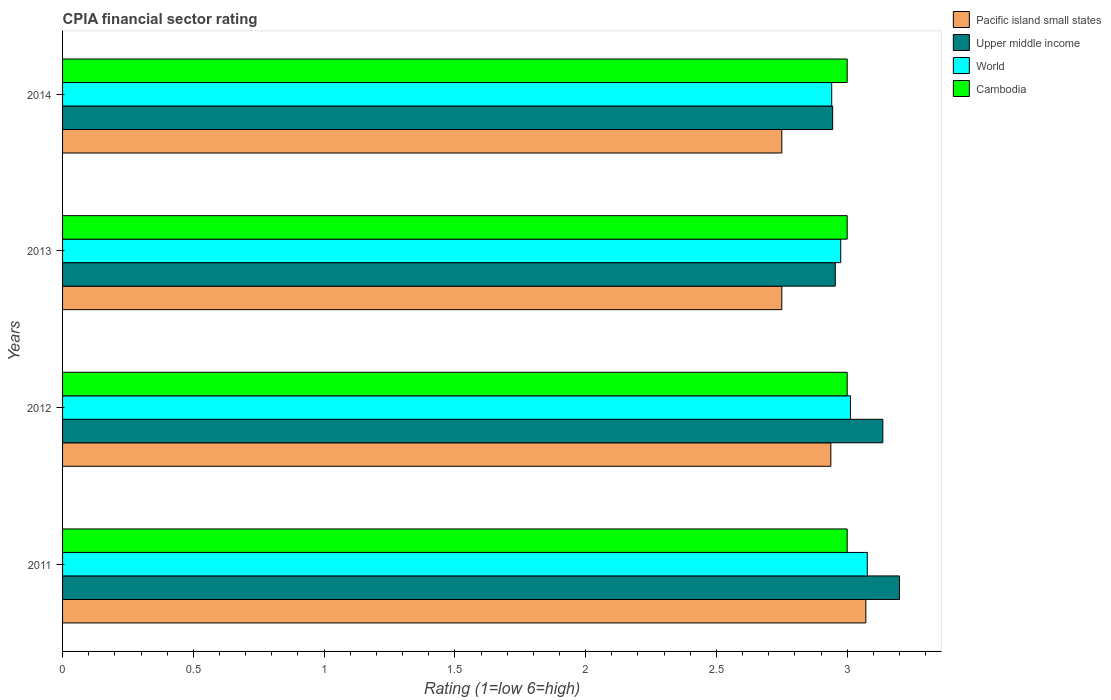How many groups of bars are there?
Keep it short and to the point. 4. Are the number of bars per tick equal to the number of legend labels?
Make the answer very short. Yes. Are the number of bars on each tick of the Y-axis equal?
Your answer should be very brief. Yes. How many bars are there on the 4th tick from the bottom?
Keep it short and to the point. 4. What is the label of the 4th group of bars from the top?
Offer a very short reply. 2011. What is the CPIA rating in World in 2014?
Ensure brevity in your answer.  2.94. Across all years, what is the maximum CPIA rating in Pacific island small states?
Give a very brief answer. 3.07. In which year was the CPIA rating in World minimum?
Keep it short and to the point. 2014. What is the total CPIA rating in World in the graph?
Offer a very short reply. 12.01. What is the difference between the CPIA rating in Upper middle income in 2014 and the CPIA rating in Pacific island small states in 2012?
Your answer should be compact. 0.01. What is the average CPIA rating in Pacific island small states per year?
Offer a very short reply. 2.88. In the year 2014, what is the difference between the CPIA rating in Cambodia and CPIA rating in Upper middle income?
Provide a succinct answer. 0.06. Is the difference between the CPIA rating in Cambodia in 2011 and 2012 greater than the difference between the CPIA rating in Upper middle income in 2011 and 2012?
Offer a very short reply. No. What is the difference between the highest and the second highest CPIA rating in World?
Ensure brevity in your answer.  0.06. What is the difference between the highest and the lowest CPIA rating in Pacific island small states?
Offer a very short reply. 0.32. In how many years, is the CPIA rating in Pacific island small states greater than the average CPIA rating in Pacific island small states taken over all years?
Ensure brevity in your answer.  2. Is the sum of the CPIA rating in World in 2012 and 2014 greater than the maximum CPIA rating in Pacific island small states across all years?
Provide a short and direct response. Yes. Is it the case that in every year, the sum of the CPIA rating in Cambodia and CPIA rating in World is greater than the sum of CPIA rating in Upper middle income and CPIA rating in Pacific island small states?
Keep it short and to the point. No. What does the 2nd bar from the top in 2013 represents?
Your answer should be compact. World. What does the 2nd bar from the bottom in 2013 represents?
Keep it short and to the point. Upper middle income. What is the difference between two consecutive major ticks on the X-axis?
Make the answer very short. 0.5. Are the values on the major ticks of X-axis written in scientific E-notation?
Your answer should be very brief. No. Does the graph contain any zero values?
Make the answer very short. No. Does the graph contain grids?
Keep it short and to the point. No. How many legend labels are there?
Offer a terse response. 4. What is the title of the graph?
Your response must be concise. CPIA financial sector rating. What is the label or title of the X-axis?
Give a very brief answer. Rating (1=low 6=high). What is the Rating (1=low 6=high) in Pacific island small states in 2011?
Offer a terse response. 3.07. What is the Rating (1=low 6=high) of World in 2011?
Your answer should be compact. 3.08. What is the Rating (1=low 6=high) in Cambodia in 2011?
Make the answer very short. 3. What is the Rating (1=low 6=high) in Pacific island small states in 2012?
Keep it short and to the point. 2.94. What is the Rating (1=low 6=high) of Upper middle income in 2012?
Ensure brevity in your answer.  3.14. What is the Rating (1=low 6=high) of World in 2012?
Your answer should be very brief. 3.01. What is the Rating (1=low 6=high) in Cambodia in 2012?
Provide a short and direct response. 3. What is the Rating (1=low 6=high) of Pacific island small states in 2013?
Your response must be concise. 2.75. What is the Rating (1=low 6=high) of Upper middle income in 2013?
Make the answer very short. 2.95. What is the Rating (1=low 6=high) in World in 2013?
Make the answer very short. 2.98. What is the Rating (1=low 6=high) in Pacific island small states in 2014?
Your answer should be compact. 2.75. What is the Rating (1=low 6=high) of Upper middle income in 2014?
Your answer should be very brief. 2.94. What is the Rating (1=low 6=high) in World in 2014?
Your answer should be very brief. 2.94. What is the Rating (1=low 6=high) of Cambodia in 2014?
Your answer should be compact. 3. Across all years, what is the maximum Rating (1=low 6=high) in Pacific island small states?
Provide a short and direct response. 3.07. Across all years, what is the maximum Rating (1=low 6=high) of World?
Ensure brevity in your answer.  3.08. Across all years, what is the minimum Rating (1=low 6=high) of Pacific island small states?
Make the answer very short. 2.75. Across all years, what is the minimum Rating (1=low 6=high) in Upper middle income?
Provide a succinct answer. 2.94. Across all years, what is the minimum Rating (1=low 6=high) of World?
Ensure brevity in your answer.  2.94. What is the total Rating (1=low 6=high) in Pacific island small states in the graph?
Make the answer very short. 11.51. What is the total Rating (1=low 6=high) of Upper middle income in the graph?
Give a very brief answer. 12.24. What is the total Rating (1=low 6=high) in World in the graph?
Keep it short and to the point. 12.01. What is the difference between the Rating (1=low 6=high) of Pacific island small states in 2011 and that in 2012?
Provide a succinct answer. 0.13. What is the difference between the Rating (1=low 6=high) of Upper middle income in 2011 and that in 2012?
Your response must be concise. 0.06. What is the difference between the Rating (1=low 6=high) of World in 2011 and that in 2012?
Offer a very short reply. 0.06. What is the difference between the Rating (1=low 6=high) in Cambodia in 2011 and that in 2012?
Provide a short and direct response. 0. What is the difference between the Rating (1=low 6=high) in Pacific island small states in 2011 and that in 2013?
Your response must be concise. 0.32. What is the difference between the Rating (1=low 6=high) in Upper middle income in 2011 and that in 2013?
Offer a terse response. 0.25. What is the difference between the Rating (1=low 6=high) of World in 2011 and that in 2013?
Your answer should be very brief. 0.1. What is the difference between the Rating (1=low 6=high) in Pacific island small states in 2011 and that in 2014?
Ensure brevity in your answer.  0.32. What is the difference between the Rating (1=low 6=high) of Upper middle income in 2011 and that in 2014?
Provide a succinct answer. 0.26. What is the difference between the Rating (1=low 6=high) in World in 2011 and that in 2014?
Ensure brevity in your answer.  0.14. What is the difference between the Rating (1=low 6=high) of Pacific island small states in 2012 and that in 2013?
Ensure brevity in your answer.  0.19. What is the difference between the Rating (1=low 6=high) in Upper middle income in 2012 and that in 2013?
Keep it short and to the point. 0.18. What is the difference between the Rating (1=low 6=high) of World in 2012 and that in 2013?
Offer a very short reply. 0.04. What is the difference between the Rating (1=low 6=high) in Pacific island small states in 2012 and that in 2014?
Provide a succinct answer. 0.19. What is the difference between the Rating (1=low 6=high) in Upper middle income in 2012 and that in 2014?
Provide a short and direct response. 0.19. What is the difference between the Rating (1=low 6=high) in World in 2012 and that in 2014?
Offer a very short reply. 0.07. What is the difference between the Rating (1=low 6=high) in Upper middle income in 2013 and that in 2014?
Offer a terse response. 0.01. What is the difference between the Rating (1=low 6=high) of World in 2013 and that in 2014?
Your answer should be very brief. 0.03. What is the difference between the Rating (1=low 6=high) of Pacific island small states in 2011 and the Rating (1=low 6=high) of Upper middle income in 2012?
Provide a short and direct response. -0.06. What is the difference between the Rating (1=low 6=high) in Pacific island small states in 2011 and the Rating (1=low 6=high) in World in 2012?
Keep it short and to the point. 0.06. What is the difference between the Rating (1=low 6=high) of Pacific island small states in 2011 and the Rating (1=low 6=high) of Cambodia in 2012?
Give a very brief answer. 0.07. What is the difference between the Rating (1=low 6=high) in Upper middle income in 2011 and the Rating (1=low 6=high) in World in 2012?
Ensure brevity in your answer.  0.19. What is the difference between the Rating (1=low 6=high) in World in 2011 and the Rating (1=low 6=high) in Cambodia in 2012?
Offer a terse response. 0.08. What is the difference between the Rating (1=low 6=high) of Pacific island small states in 2011 and the Rating (1=low 6=high) of Upper middle income in 2013?
Provide a short and direct response. 0.12. What is the difference between the Rating (1=low 6=high) of Pacific island small states in 2011 and the Rating (1=low 6=high) of World in 2013?
Keep it short and to the point. 0.1. What is the difference between the Rating (1=low 6=high) of Pacific island small states in 2011 and the Rating (1=low 6=high) of Cambodia in 2013?
Offer a very short reply. 0.07. What is the difference between the Rating (1=low 6=high) in Upper middle income in 2011 and the Rating (1=low 6=high) in World in 2013?
Provide a short and direct response. 0.22. What is the difference between the Rating (1=low 6=high) of World in 2011 and the Rating (1=low 6=high) of Cambodia in 2013?
Your answer should be very brief. 0.08. What is the difference between the Rating (1=low 6=high) of Pacific island small states in 2011 and the Rating (1=low 6=high) of Upper middle income in 2014?
Your answer should be very brief. 0.13. What is the difference between the Rating (1=low 6=high) in Pacific island small states in 2011 and the Rating (1=low 6=high) in World in 2014?
Your answer should be compact. 0.13. What is the difference between the Rating (1=low 6=high) of Pacific island small states in 2011 and the Rating (1=low 6=high) of Cambodia in 2014?
Offer a terse response. 0.07. What is the difference between the Rating (1=low 6=high) of Upper middle income in 2011 and the Rating (1=low 6=high) of World in 2014?
Offer a very short reply. 0.26. What is the difference between the Rating (1=low 6=high) of Upper middle income in 2011 and the Rating (1=low 6=high) of Cambodia in 2014?
Give a very brief answer. 0.2. What is the difference between the Rating (1=low 6=high) in World in 2011 and the Rating (1=low 6=high) in Cambodia in 2014?
Provide a succinct answer. 0.08. What is the difference between the Rating (1=low 6=high) of Pacific island small states in 2012 and the Rating (1=low 6=high) of Upper middle income in 2013?
Provide a short and direct response. -0.02. What is the difference between the Rating (1=low 6=high) of Pacific island small states in 2012 and the Rating (1=low 6=high) of World in 2013?
Provide a short and direct response. -0.04. What is the difference between the Rating (1=low 6=high) of Pacific island small states in 2012 and the Rating (1=low 6=high) of Cambodia in 2013?
Your response must be concise. -0.06. What is the difference between the Rating (1=low 6=high) of Upper middle income in 2012 and the Rating (1=low 6=high) of World in 2013?
Offer a terse response. 0.16. What is the difference between the Rating (1=low 6=high) of Upper middle income in 2012 and the Rating (1=low 6=high) of Cambodia in 2013?
Offer a terse response. 0.14. What is the difference between the Rating (1=low 6=high) in World in 2012 and the Rating (1=low 6=high) in Cambodia in 2013?
Make the answer very short. 0.01. What is the difference between the Rating (1=low 6=high) of Pacific island small states in 2012 and the Rating (1=low 6=high) of Upper middle income in 2014?
Make the answer very short. -0.01. What is the difference between the Rating (1=low 6=high) in Pacific island small states in 2012 and the Rating (1=low 6=high) in World in 2014?
Provide a short and direct response. -0. What is the difference between the Rating (1=low 6=high) of Pacific island small states in 2012 and the Rating (1=low 6=high) of Cambodia in 2014?
Your answer should be compact. -0.06. What is the difference between the Rating (1=low 6=high) of Upper middle income in 2012 and the Rating (1=low 6=high) of World in 2014?
Offer a very short reply. 0.2. What is the difference between the Rating (1=low 6=high) of Upper middle income in 2012 and the Rating (1=low 6=high) of Cambodia in 2014?
Give a very brief answer. 0.14. What is the difference between the Rating (1=low 6=high) in World in 2012 and the Rating (1=low 6=high) in Cambodia in 2014?
Offer a very short reply. 0.01. What is the difference between the Rating (1=low 6=high) in Pacific island small states in 2013 and the Rating (1=low 6=high) in Upper middle income in 2014?
Make the answer very short. -0.19. What is the difference between the Rating (1=low 6=high) of Pacific island small states in 2013 and the Rating (1=low 6=high) of World in 2014?
Your response must be concise. -0.19. What is the difference between the Rating (1=low 6=high) of Upper middle income in 2013 and the Rating (1=low 6=high) of World in 2014?
Your response must be concise. 0.01. What is the difference between the Rating (1=low 6=high) in Upper middle income in 2013 and the Rating (1=low 6=high) in Cambodia in 2014?
Provide a short and direct response. -0.05. What is the difference between the Rating (1=low 6=high) in World in 2013 and the Rating (1=low 6=high) in Cambodia in 2014?
Your response must be concise. -0.02. What is the average Rating (1=low 6=high) of Pacific island small states per year?
Your response must be concise. 2.88. What is the average Rating (1=low 6=high) in Upper middle income per year?
Keep it short and to the point. 3.06. What is the average Rating (1=low 6=high) in World per year?
Your answer should be compact. 3. In the year 2011, what is the difference between the Rating (1=low 6=high) of Pacific island small states and Rating (1=low 6=high) of Upper middle income?
Provide a short and direct response. -0.13. In the year 2011, what is the difference between the Rating (1=low 6=high) in Pacific island small states and Rating (1=low 6=high) in World?
Keep it short and to the point. -0.01. In the year 2011, what is the difference between the Rating (1=low 6=high) in Pacific island small states and Rating (1=low 6=high) in Cambodia?
Ensure brevity in your answer.  0.07. In the year 2011, what is the difference between the Rating (1=low 6=high) in Upper middle income and Rating (1=low 6=high) in World?
Give a very brief answer. 0.12. In the year 2011, what is the difference between the Rating (1=low 6=high) in World and Rating (1=low 6=high) in Cambodia?
Your answer should be compact. 0.08. In the year 2012, what is the difference between the Rating (1=low 6=high) of Pacific island small states and Rating (1=low 6=high) of Upper middle income?
Provide a succinct answer. -0.2. In the year 2012, what is the difference between the Rating (1=low 6=high) in Pacific island small states and Rating (1=low 6=high) in World?
Provide a short and direct response. -0.07. In the year 2012, what is the difference between the Rating (1=low 6=high) of Pacific island small states and Rating (1=low 6=high) of Cambodia?
Offer a very short reply. -0.06. In the year 2012, what is the difference between the Rating (1=low 6=high) in Upper middle income and Rating (1=low 6=high) in World?
Offer a terse response. 0.12. In the year 2012, what is the difference between the Rating (1=low 6=high) of Upper middle income and Rating (1=low 6=high) of Cambodia?
Provide a short and direct response. 0.14. In the year 2012, what is the difference between the Rating (1=low 6=high) of World and Rating (1=low 6=high) of Cambodia?
Keep it short and to the point. 0.01. In the year 2013, what is the difference between the Rating (1=low 6=high) in Pacific island small states and Rating (1=low 6=high) in Upper middle income?
Offer a terse response. -0.2. In the year 2013, what is the difference between the Rating (1=low 6=high) in Pacific island small states and Rating (1=low 6=high) in World?
Your answer should be compact. -0.23. In the year 2013, what is the difference between the Rating (1=low 6=high) of Upper middle income and Rating (1=low 6=high) of World?
Your response must be concise. -0.02. In the year 2013, what is the difference between the Rating (1=low 6=high) in Upper middle income and Rating (1=low 6=high) in Cambodia?
Give a very brief answer. -0.05. In the year 2013, what is the difference between the Rating (1=low 6=high) of World and Rating (1=low 6=high) of Cambodia?
Provide a succinct answer. -0.02. In the year 2014, what is the difference between the Rating (1=low 6=high) in Pacific island small states and Rating (1=low 6=high) in Upper middle income?
Your answer should be compact. -0.19. In the year 2014, what is the difference between the Rating (1=low 6=high) in Pacific island small states and Rating (1=low 6=high) in World?
Keep it short and to the point. -0.19. In the year 2014, what is the difference between the Rating (1=low 6=high) of Pacific island small states and Rating (1=low 6=high) of Cambodia?
Ensure brevity in your answer.  -0.25. In the year 2014, what is the difference between the Rating (1=low 6=high) of Upper middle income and Rating (1=low 6=high) of World?
Your answer should be very brief. 0. In the year 2014, what is the difference between the Rating (1=low 6=high) of Upper middle income and Rating (1=low 6=high) of Cambodia?
Your response must be concise. -0.06. In the year 2014, what is the difference between the Rating (1=low 6=high) of World and Rating (1=low 6=high) of Cambodia?
Offer a terse response. -0.06. What is the ratio of the Rating (1=low 6=high) in Pacific island small states in 2011 to that in 2012?
Offer a very short reply. 1.05. What is the ratio of the Rating (1=low 6=high) in Upper middle income in 2011 to that in 2012?
Make the answer very short. 1.02. What is the ratio of the Rating (1=low 6=high) in World in 2011 to that in 2012?
Offer a terse response. 1.02. What is the ratio of the Rating (1=low 6=high) in Cambodia in 2011 to that in 2012?
Make the answer very short. 1. What is the ratio of the Rating (1=low 6=high) of Pacific island small states in 2011 to that in 2013?
Offer a very short reply. 1.12. What is the ratio of the Rating (1=low 6=high) of Upper middle income in 2011 to that in 2013?
Give a very brief answer. 1.08. What is the ratio of the Rating (1=low 6=high) of World in 2011 to that in 2013?
Offer a terse response. 1.03. What is the ratio of the Rating (1=low 6=high) in Cambodia in 2011 to that in 2013?
Give a very brief answer. 1. What is the ratio of the Rating (1=low 6=high) of Pacific island small states in 2011 to that in 2014?
Keep it short and to the point. 1.12. What is the ratio of the Rating (1=low 6=high) of Upper middle income in 2011 to that in 2014?
Your response must be concise. 1.09. What is the ratio of the Rating (1=low 6=high) of World in 2011 to that in 2014?
Your response must be concise. 1.05. What is the ratio of the Rating (1=low 6=high) of Cambodia in 2011 to that in 2014?
Ensure brevity in your answer.  1. What is the ratio of the Rating (1=low 6=high) of Pacific island small states in 2012 to that in 2013?
Offer a very short reply. 1.07. What is the ratio of the Rating (1=low 6=high) in Upper middle income in 2012 to that in 2013?
Make the answer very short. 1.06. What is the ratio of the Rating (1=low 6=high) of World in 2012 to that in 2013?
Your response must be concise. 1.01. What is the ratio of the Rating (1=low 6=high) of Pacific island small states in 2012 to that in 2014?
Your answer should be compact. 1.07. What is the ratio of the Rating (1=low 6=high) of Upper middle income in 2012 to that in 2014?
Offer a terse response. 1.07. What is the ratio of the Rating (1=low 6=high) in World in 2012 to that in 2014?
Your answer should be compact. 1.02. What is the ratio of the Rating (1=low 6=high) of Pacific island small states in 2013 to that in 2014?
Offer a terse response. 1. What is the ratio of the Rating (1=low 6=high) in Upper middle income in 2013 to that in 2014?
Your answer should be compact. 1. What is the ratio of the Rating (1=low 6=high) in World in 2013 to that in 2014?
Provide a succinct answer. 1.01. What is the ratio of the Rating (1=low 6=high) of Cambodia in 2013 to that in 2014?
Your answer should be very brief. 1. What is the difference between the highest and the second highest Rating (1=low 6=high) of Pacific island small states?
Provide a succinct answer. 0.13. What is the difference between the highest and the second highest Rating (1=low 6=high) in Upper middle income?
Keep it short and to the point. 0.06. What is the difference between the highest and the second highest Rating (1=low 6=high) in World?
Your response must be concise. 0.06. What is the difference between the highest and the second highest Rating (1=low 6=high) of Cambodia?
Your answer should be very brief. 0. What is the difference between the highest and the lowest Rating (1=low 6=high) of Pacific island small states?
Provide a short and direct response. 0.32. What is the difference between the highest and the lowest Rating (1=low 6=high) of Upper middle income?
Make the answer very short. 0.26. What is the difference between the highest and the lowest Rating (1=low 6=high) in World?
Your answer should be very brief. 0.14. What is the difference between the highest and the lowest Rating (1=low 6=high) of Cambodia?
Your answer should be compact. 0. 